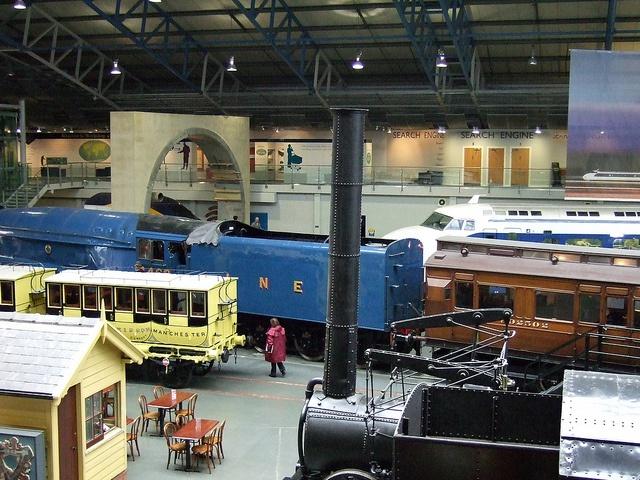Describe the objects in this image and their specific colors. I can see train in black, white, gray, and darkgray tones, train in black, blue, and navy tones, train in black, maroon, and darkgray tones, train in black, ivory, and khaki tones, and train in black, white, darkgray, lightgray, and gray tones in this image. 